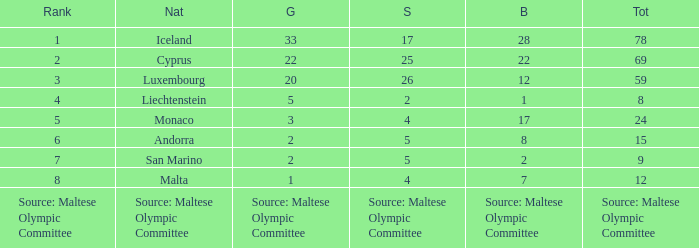What is the total medal count for the nation that has 5 gold? 8.0. 